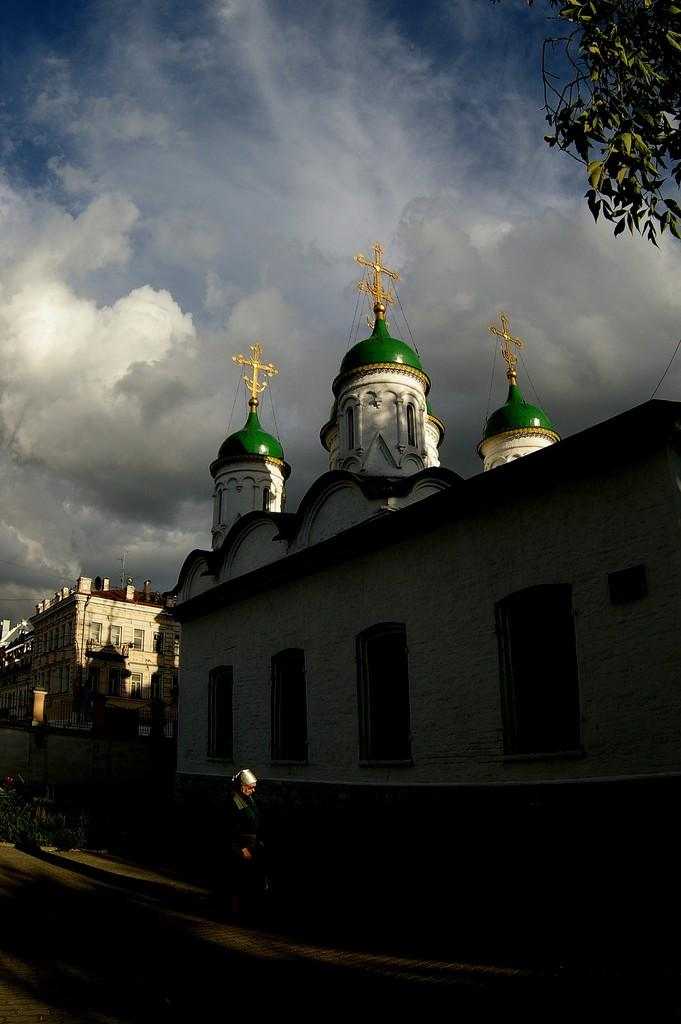What is the person in the image doing? There is a person walking in the image. What can be seen in the background of the image? There is a building and trees in the background of the image. What are the colors of the building in the background? The building is green and white in color. What is the color of the trees in the background? The trees are green in color. What is visible in the sky in the background of the image? The sky is blue and white in color. What type of secretary can be seen working in the image? There is no secretary present in the image; it only shows a person walking and the background elements. 